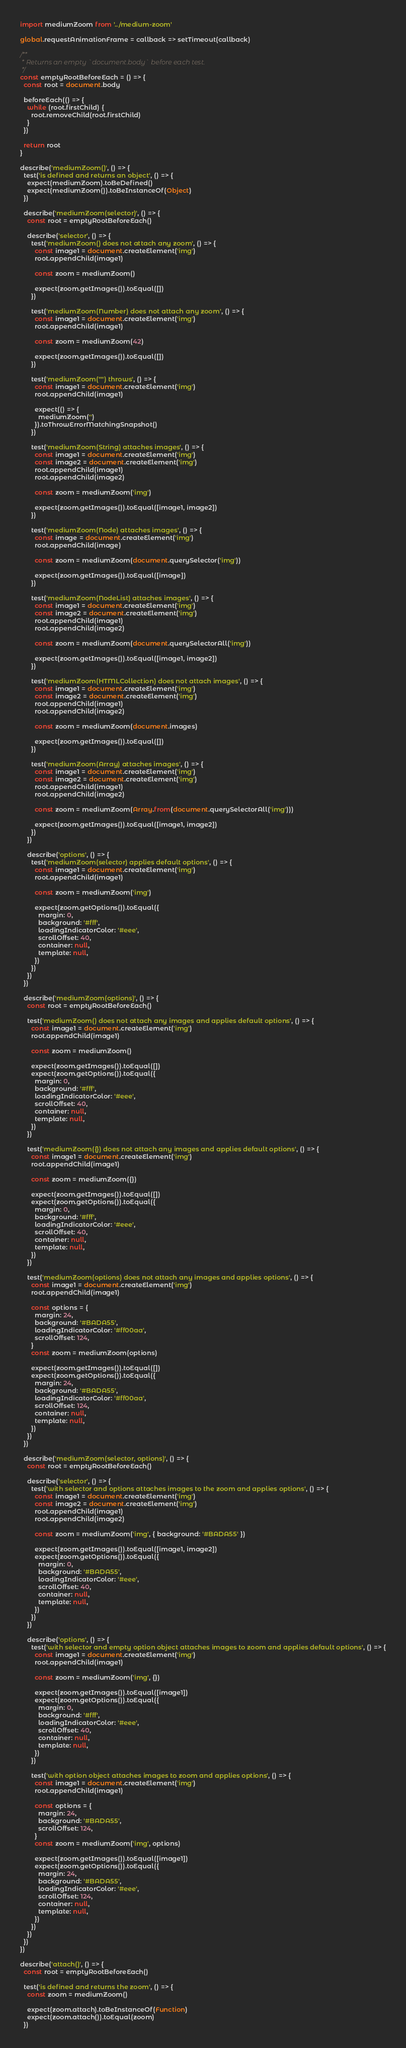Convert code to text. <code><loc_0><loc_0><loc_500><loc_500><_JavaScript_>import mediumZoom from '../medium-zoom'

global.requestAnimationFrame = callback => setTimeout(callback)

/**
 * Returns an empty `document.body` before each test.
 */
const emptyRootBeforeEach = () => {
  const root = document.body

  beforeEach(() => {
    while (root.firstChild) {
      root.removeChild(root.firstChild)
    }
  })

  return root
}

describe('mediumZoom()', () => {
  test('is defined and returns an object', () => {
    expect(mediumZoom).toBeDefined()
    expect(mediumZoom()).toBeInstanceOf(Object)
  })

  describe('mediumZoom(selector)', () => {
    const root = emptyRootBeforeEach()

    describe('selector', () => {
      test('mediumZoom() does not attach any zoom', () => {
        const image1 = document.createElement('img')
        root.appendChild(image1)

        const zoom = mediumZoom()

        expect(zoom.getImages()).toEqual([])
      })

      test('mediumZoom(Number) does not attach any zoom', () => {
        const image1 = document.createElement('img')
        root.appendChild(image1)

        const zoom = mediumZoom(42)

        expect(zoom.getImages()).toEqual([])
      })

      test('mediumZoom("") throws', () => {
        const image1 = document.createElement('img')
        root.appendChild(image1)

        expect(() => {
          mediumZoom('')
        }).toThrowErrorMatchingSnapshot()
      })

      test('mediumZoom(String) attaches images', () => {
        const image1 = document.createElement('img')
        const image2 = document.createElement('img')
        root.appendChild(image1)
        root.appendChild(image2)

        const zoom = mediumZoom('img')

        expect(zoom.getImages()).toEqual([image1, image2])
      })

      test('mediumZoom(Node) attaches images', () => {
        const image = document.createElement('img')
        root.appendChild(image)

        const zoom = mediumZoom(document.querySelector('img'))

        expect(zoom.getImages()).toEqual([image])
      })

      test('mediumZoom(NodeList) attaches images', () => {
        const image1 = document.createElement('img')
        const image2 = document.createElement('img')
        root.appendChild(image1)
        root.appendChild(image2)

        const zoom = mediumZoom(document.querySelectorAll('img'))

        expect(zoom.getImages()).toEqual([image1, image2])
      })

      test('mediumZoom(HTMLCollection) does not attach images', () => {
        const image1 = document.createElement('img')
        const image2 = document.createElement('img')
        root.appendChild(image1)
        root.appendChild(image2)

        const zoom = mediumZoom(document.images)

        expect(zoom.getImages()).toEqual([])
      })

      test('mediumZoom(Array) attaches images', () => {
        const image1 = document.createElement('img')
        const image2 = document.createElement('img')
        root.appendChild(image1)
        root.appendChild(image2)

        const zoom = mediumZoom(Array.from(document.querySelectorAll('img')))

        expect(zoom.getImages()).toEqual([image1, image2])
      })
    })

    describe('options', () => {
      test('mediumZoom(selector) applies default options', () => {
        const image1 = document.createElement('img')
        root.appendChild(image1)

        const zoom = mediumZoom('img')

        expect(zoom.getOptions()).toEqual({
          margin: 0,
          background: '#fff',
          loadingIndicatorColor: '#eee',
          scrollOffset: 40,
          container: null,
          template: null,
        })
      })
    })
  })

  describe('mediumZoom(options)', () => {
    const root = emptyRootBeforeEach()

    test('mediumZoom() does not attach any images and applies default options', () => {
      const image1 = document.createElement('img')
      root.appendChild(image1)

      const zoom = mediumZoom()

      expect(zoom.getImages()).toEqual([])
      expect(zoom.getOptions()).toEqual({
        margin: 0,
        background: '#fff',
        loadingIndicatorColor: '#eee',
        scrollOffset: 40,
        container: null,
        template: null,
      })
    })

    test('mediumZoom({}) does not attach any images and applies default options', () => {
      const image1 = document.createElement('img')
      root.appendChild(image1)

      const zoom = mediumZoom({})

      expect(zoom.getImages()).toEqual([])
      expect(zoom.getOptions()).toEqual({
        margin: 0,
        background: '#fff',
        loadingIndicatorColor: '#eee',
        scrollOffset: 40,
        container: null,
        template: null,
      })
    })

    test('mediumZoom(options) does not attach any images and applies options', () => {
      const image1 = document.createElement('img')
      root.appendChild(image1)

      const options = {
        margin: 24,
        background: '#BADA55',
        loadingIndicatorColor: '#ff00aa',
        scrollOffset: 124,
      }
      const zoom = mediumZoom(options)

      expect(zoom.getImages()).toEqual([])
      expect(zoom.getOptions()).toEqual({
        margin: 24,
        background: '#BADA55',
        loadingIndicatorColor: '#ff00aa',
        scrollOffset: 124,
        container: null,
        template: null,
      })
    })
  })

  describe('mediumZoom(selector, options)', () => {
    const root = emptyRootBeforeEach()

    describe('selector', () => {
      test('with selector and options attaches images to the zoom and applies options', () => {
        const image1 = document.createElement('img')
        const image2 = document.createElement('img')
        root.appendChild(image1)
        root.appendChild(image2)

        const zoom = mediumZoom('img', { background: '#BADA55' })

        expect(zoom.getImages()).toEqual([image1, image2])
        expect(zoom.getOptions()).toEqual({
          margin: 0,
          background: '#BADA55',
          loadingIndicatorColor: '#eee',
          scrollOffset: 40,
          container: null,
          template: null,
        })
      })
    })

    describe('options', () => {
      test('with selector and empty option object attaches images to zoom and applies default options', () => {
        const image1 = document.createElement('img')
        root.appendChild(image1)

        const zoom = mediumZoom('img', {})

        expect(zoom.getImages()).toEqual([image1])
        expect(zoom.getOptions()).toEqual({
          margin: 0,
          background: '#fff',
          loadingIndicatorColor: '#eee',
          scrollOffset: 40,
          container: null,
          template: null,
        })
      })

      test('with option object attaches images to zoom and applies options', () => {
        const image1 = document.createElement('img')
        root.appendChild(image1)

        const options = {
          margin: 24,
          background: '#BADA55',
          scrollOffset: 124,
        }
        const zoom = mediumZoom('img', options)

        expect(zoom.getImages()).toEqual([image1])
        expect(zoom.getOptions()).toEqual({
          margin: 24,
          background: '#BADA55',
          loadingIndicatorColor: '#eee',
          scrollOffset: 124,
          container: null,
          template: null,
        })
      })
    })
  })
})

describe('attach()', () => {
  const root = emptyRootBeforeEach()

  test('is defined and returns the zoom', () => {
    const zoom = mediumZoom()

    expect(zoom.attach).toBeInstanceOf(Function)
    expect(zoom.attach()).toEqual(zoom)
  })
</code> 